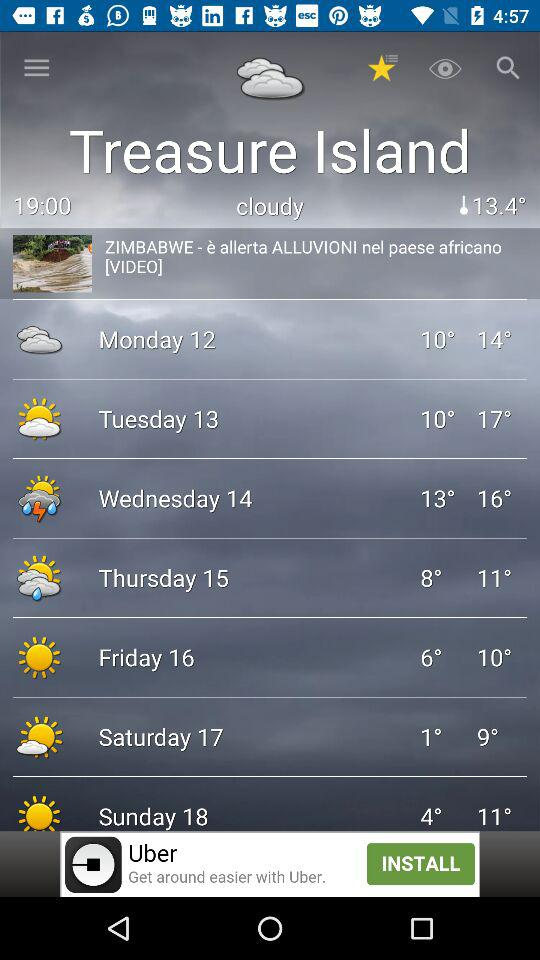What’s the weather on Wednesday?
When the provided information is insufficient, respond with <no answer>. <no answer> 